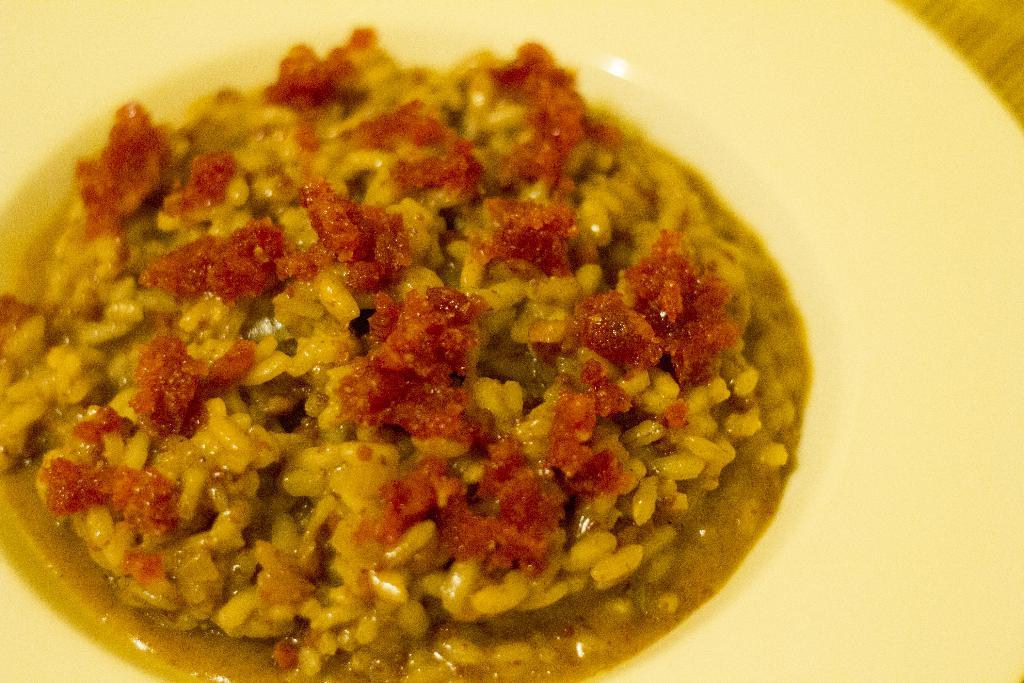What is the main subject of the image? There is a cooked food item in the image. How is the food item presented in the image? The food item is served on a plate. What type of grain is visible in the image? There is no grain visible in the image; it only features a cooked food item served on a plate. 